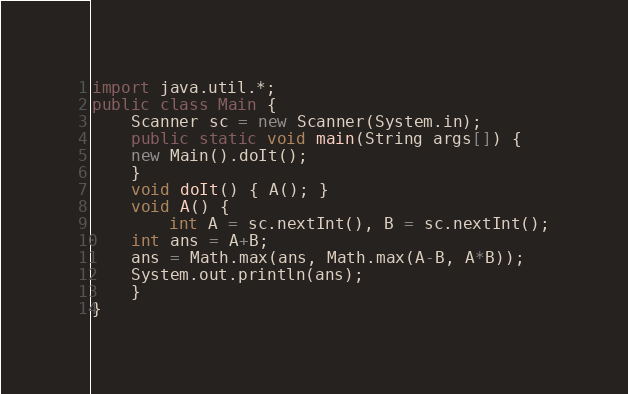<code> <loc_0><loc_0><loc_500><loc_500><_Java_>import java.util.*;
public class Main {
    Scanner sc = new Scanner(System.in);
    public static void main(String args[]) {
	new Main().doIt();
    }
    void doIt() { A(); }
    void A() {
        int A = sc.nextInt(), B = sc.nextInt();
	int ans = A+B;
	ans = Math.max(ans, Math.max(A-B, A*B));
	System.out.println(ans);
    }
}
</code> 